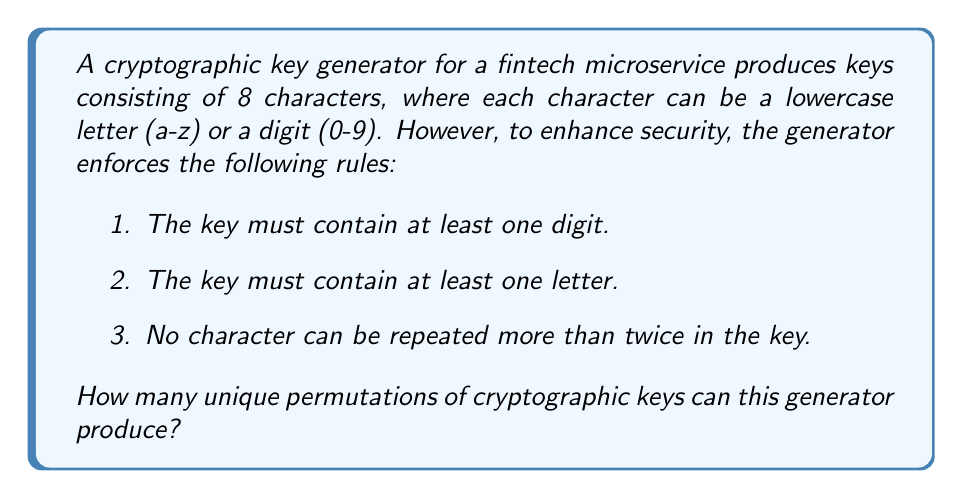Provide a solution to this math problem. Let's approach this step-by-step:

1) First, we need to calculate the total number of characters available:
   26 lowercase letters + 10 digits = 36 characters

2) Without any restrictions, we would have $36^8$ total permutations.

3) Now, let's consider the restrictions:

   a) To ensure at least one digit and one letter, we can use the principle of inclusion-exclusion:

      Total = All - (No digits + No letters - No digits AND no letters)

      $$ \text{Total} = 36^8 - (26^8 + 10^8 - 0^8) $$

   b) For the restriction of no character repeating more than twice, we can use the exponential generating function:

      $$ f(x) = (1 + x + \frac{x^2}{2!})^{36} $$

      The coefficient of $x^8$ in the expansion of this function will give us the number of permutations satisfying this condition.

4) Combining these restrictions:

   $$ \text{Result} = [x^8]\left((1 + x + \frac{x^2}{2!})^{36}\right) - ([x^8]\left((1 + x + \frac{x^2}{2!})^{26}\right) + [x^8]\left((1 + x + \frac{x^2}{2!})^{10}\right)) $$

   Where $[x^8]$ denotes the coefficient of $x^8$ in the expansion.

5) Calculating this:
   
   $$ \text{Result} = 1,642,888,344,544 - (3,315,312,000 + 1,814,400) = 1,639,571,218,144 $$

Therefore, the cryptographic key generator can produce 1,639,571,218,144 unique permutations of keys satisfying all the given conditions.
Answer: 1,639,571,218,144 unique permutations 